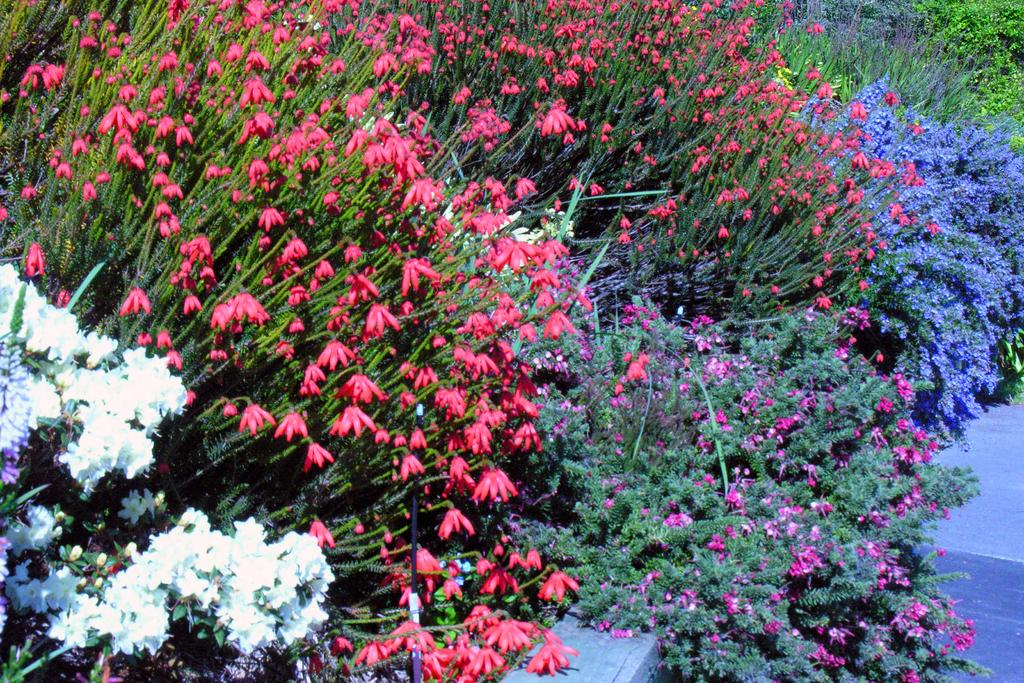What type of living organisms can be seen in the image? Plants can be seen in the image. What specific features are present on the plants? The plants have flowers. How diverse are the flowers in terms of color? The flowers have different colors. What type of nerve can be seen in the image? There is no nerve present in the image; it features plants with flowers. What type of stew is being prepared in the image? There is no stew being prepared in the image; it features plants with flowers. 